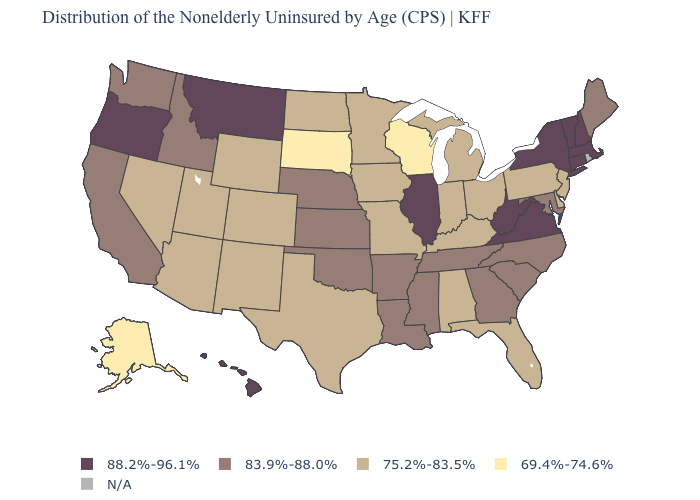Which states have the lowest value in the Northeast?
Be succinct. New Jersey, Pennsylvania. What is the value of Iowa?
Quick response, please. 75.2%-83.5%. What is the value of Kansas?
Answer briefly. 83.9%-88.0%. Among the states that border Georgia , which have the lowest value?
Concise answer only. Alabama, Florida. Does Oregon have the lowest value in the West?
Concise answer only. No. Among the states that border Rhode Island , which have the lowest value?
Concise answer only. Connecticut, Massachusetts. What is the value of Maine?
Answer briefly. 83.9%-88.0%. Name the states that have a value in the range 69.4%-74.6%?
Write a very short answer. Alaska, South Dakota, Wisconsin. Which states have the lowest value in the Northeast?
Give a very brief answer. New Jersey, Pennsylvania. What is the highest value in the USA?
Be succinct. 88.2%-96.1%. Name the states that have a value in the range N/A?
Keep it brief. Rhode Island. Which states have the lowest value in the USA?
Short answer required. Alaska, South Dakota, Wisconsin. What is the lowest value in the USA?
Be succinct. 69.4%-74.6%. What is the value of Illinois?
Keep it brief. 88.2%-96.1%. 